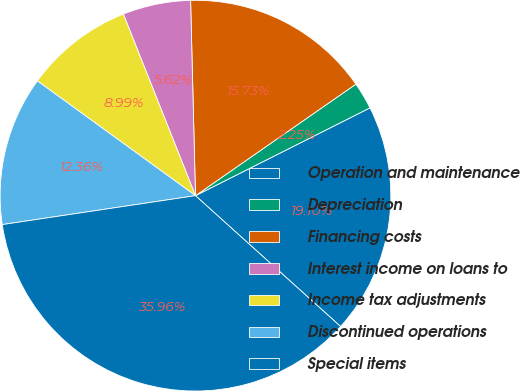Convert chart to OTSL. <chart><loc_0><loc_0><loc_500><loc_500><pie_chart><fcel>Operation and maintenance<fcel>Depreciation<fcel>Financing costs<fcel>Interest income on loans to<fcel>Income tax adjustments<fcel>Discontinued operations<fcel>Special items<nl><fcel>19.1%<fcel>2.25%<fcel>15.73%<fcel>5.62%<fcel>8.99%<fcel>12.36%<fcel>35.96%<nl></chart> 